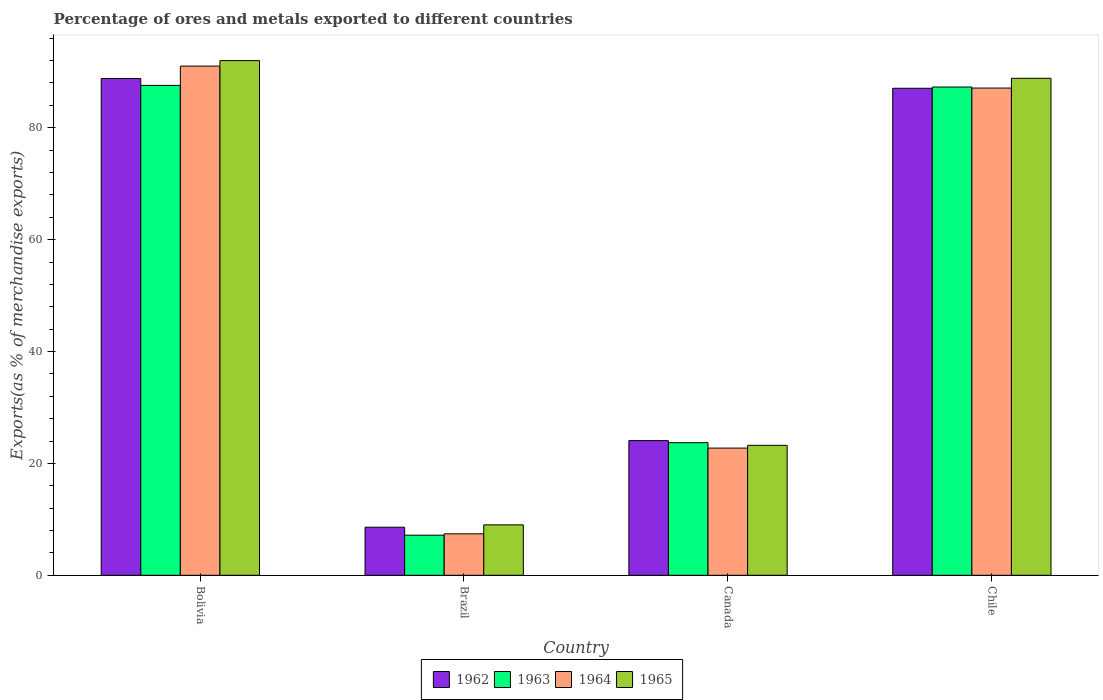How many bars are there on the 2nd tick from the left?
Your answer should be very brief. 4. What is the label of the 2nd group of bars from the left?
Provide a succinct answer. Brazil. What is the percentage of exports to different countries in 1962 in Brazil?
Your answer should be very brief. 8.59. Across all countries, what is the maximum percentage of exports to different countries in 1963?
Make the answer very short. 87.57. Across all countries, what is the minimum percentage of exports to different countries in 1965?
Make the answer very short. 9.01. In which country was the percentage of exports to different countries in 1963 maximum?
Your response must be concise. Bolivia. In which country was the percentage of exports to different countries in 1963 minimum?
Your answer should be very brief. Brazil. What is the total percentage of exports to different countries in 1965 in the graph?
Provide a short and direct response. 213.07. What is the difference between the percentage of exports to different countries in 1963 in Bolivia and that in Canada?
Your answer should be compact. 63.86. What is the difference between the percentage of exports to different countries in 1965 in Bolivia and the percentage of exports to different countries in 1964 in Chile?
Make the answer very short. 4.9. What is the average percentage of exports to different countries in 1963 per country?
Your response must be concise. 51.43. What is the difference between the percentage of exports to different countries of/in 1965 and percentage of exports to different countries of/in 1963 in Bolivia?
Provide a succinct answer. 4.43. What is the ratio of the percentage of exports to different countries in 1964 in Bolivia to that in Canada?
Give a very brief answer. 4. Is the difference between the percentage of exports to different countries in 1965 in Bolivia and Brazil greater than the difference between the percentage of exports to different countries in 1963 in Bolivia and Brazil?
Offer a very short reply. Yes. What is the difference between the highest and the second highest percentage of exports to different countries in 1965?
Offer a terse response. -3.16. What is the difference between the highest and the lowest percentage of exports to different countries in 1962?
Ensure brevity in your answer.  80.2. In how many countries, is the percentage of exports to different countries in 1963 greater than the average percentage of exports to different countries in 1963 taken over all countries?
Your answer should be very brief. 2. Is the sum of the percentage of exports to different countries in 1962 in Brazil and Canada greater than the maximum percentage of exports to different countries in 1963 across all countries?
Make the answer very short. No. Is it the case that in every country, the sum of the percentage of exports to different countries in 1965 and percentage of exports to different countries in 1964 is greater than the sum of percentage of exports to different countries in 1962 and percentage of exports to different countries in 1963?
Your answer should be compact. No. What does the 1st bar from the right in Brazil represents?
Make the answer very short. 1965. Are all the bars in the graph horizontal?
Make the answer very short. No. How many countries are there in the graph?
Make the answer very short. 4. Are the values on the major ticks of Y-axis written in scientific E-notation?
Your response must be concise. No. Does the graph contain any zero values?
Your answer should be compact. No. Where does the legend appear in the graph?
Your response must be concise. Bottom center. How many legend labels are there?
Offer a very short reply. 4. How are the legend labels stacked?
Your answer should be compact. Horizontal. What is the title of the graph?
Your answer should be very brief. Percentage of ores and metals exported to different countries. Does "1991" appear as one of the legend labels in the graph?
Offer a terse response. No. What is the label or title of the Y-axis?
Provide a short and direct response. Exports(as % of merchandise exports). What is the Exports(as % of merchandise exports) of 1962 in Bolivia?
Your answer should be very brief. 88.79. What is the Exports(as % of merchandise exports) in 1963 in Bolivia?
Give a very brief answer. 87.57. What is the Exports(as % of merchandise exports) of 1964 in Bolivia?
Give a very brief answer. 91.02. What is the Exports(as % of merchandise exports) in 1965 in Bolivia?
Make the answer very short. 92. What is the Exports(as % of merchandise exports) in 1962 in Brazil?
Offer a terse response. 8.59. What is the Exports(as % of merchandise exports) in 1963 in Brazil?
Provide a short and direct response. 7.17. What is the Exports(as % of merchandise exports) of 1964 in Brazil?
Offer a terse response. 7.41. What is the Exports(as % of merchandise exports) of 1965 in Brazil?
Offer a terse response. 9.01. What is the Exports(as % of merchandise exports) in 1962 in Canada?
Keep it short and to the point. 24.07. What is the Exports(as % of merchandise exports) in 1963 in Canada?
Your response must be concise. 23.71. What is the Exports(as % of merchandise exports) of 1964 in Canada?
Ensure brevity in your answer.  22.74. What is the Exports(as % of merchandise exports) in 1965 in Canada?
Your answer should be compact. 23.23. What is the Exports(as % of merchandise exports) in 1962 in Chile?
Keep it short and to the point. 87.06. What is the Exports(as % of merchandise exports) in 1963 in Chile?
Provide a succinct answer. 87.28. What is the Exports(as % of merchandise exports) of 1964 in Chile?
Offer a terse response. 87.1. What is the Exports(as % of merchandise exports) of 1965 in Chile?
Provide a succinct answer. 88.84. Across all countries, what is the maximum Exports(as % of merchandise exports) in 1962?
Keep it short and to the point. 88.79. Across all countries, what is the maximum Exports(as % of merchandise exports) in 1963?
Your answer should be compact. 87.57. Across all countries, what is the maximum Exports(as % of merchandise exports) of 1964?
Your answer should be very brief. 91.02. Across all countries, what is the maximum Exports(as % of merchandise exports) in 1965?
Offer a very short reply. 92. Across all countries, what is the minimum Exports(as % of merchandise exports) of 1962?
Make the answer very short. 8.59. Across all countries, what is the minimum Exports(as % of merchandise exports) in 1963?
Keep it short and to the point. 7.17. Across all countries, what is the minimum Exports(as % of merchandise exports) of 1964?
Provide a short and direct response. 7.41. Across all countries, what is the minimum Exports(as % of merchandise exports) in 1965?
Your response must be concise. 9.01. What is the total Exports(as % of merchandise exports) of 1962 in the graph?
Your answer should be compact. 208.51. What is the total Exports(as % of merchandise exports) of 1963 in the graph?
Ensure brevity in your answer.  205.73. What is the total Exports(as % of merchandise exports) in 1964 in the graph?
Your answer should be very brief. 208.26. What is the total Exports(as % of merchandise exports) of 1965 in the graph?
Keep it short and to the point. 213.07. What is the difference between the Exports(as % of merchandise exports) of 1962 in Bolivia and that in Brazil?
Ensure brevity in your answer.  80.2. What is the difference between the Exports(as % of merchandise exports) in 1963 in Bolivia and that in Brazil?
Your response must be concise. 80.4. What is the difference between the Exports(as % of merchandise exports) of 1964 in Bolivia and that in Brazil?
Your response must be concise. 83.61. What is the difference between the Exports(as % of merchandise exports) in 1965 in Bolivia and that in Brazil?
Your answer should be very brief. 82.99. What is the difference between the Exports(as % of merchandise exports) of 1962 in Bolivia and that in Canada?
Your response must be concise. 64.72. What is the difference between the Exports(as % of merchandise exports) of 1963 in Bolivia and that in Canada?
Offer a very short reply. 63.86. What is the difference between the Exports(as % of merchandise exports) in 1964 in Bolivia and that in Canada?
Provide a succinct answer. 68.28. What is the difference between the Exports(as % of merchandise exports) in 1965 in Bolivia and that in Canada?
Ensure brevity in your answer.  68.77. What is the difference between the Exports(as % of merchandise exports) of 1962 in Bolivia and that in Chile?
Provide a short and direct response. 1.74. What is the difference between the Exports(as % of merchandise exports) of 1963 in Bolivia and that in Chile?
Ensure brevity in your answer.  0.29. What is the difference between the Exports(as % of merchandise exports) in 1964 in Bolivia and that in Chile?
Keep it short and to the point. 3.92. What is the difference between the Exports(as % of merchandise exports) in 1965 in Bolivia and that in Chile?
Your answer should be very brief. 3.16. What is the difference between the Exports(as % of merchandise exports) in 1962 in Brazil and that in Canada?
Your answer should be compact. -15.48. What is the difference between the Exports(as % of merchandise exports) in 1963 in Brazil and that in Canada?
Your answer should be compact. -16.54. What is the difference between the Exports(as % of merchandise exports) of 1964 in Brazil and that in Canada?
Your answer should be compact. -15.33. What is the difference between the Exports(as % of merchandise exports) of 1965 in Brazil and that in Canada?
Offer a very short reply. -14.22. What is the difference between the Exports(as % of merchandise exports) of 1962 in Brazil and that in Chile?
Offer a terse response. -78.46. What is the difference between the Exports(as % of merchandise exports) in 1963 in Brazil and that in Chile?
Provide a short and direct response. -80.11. What is the difference between the Exports(as % of merchandise exports) of 1964 in Brazil and that in Chile?
Your answer should be compact. -79.69. What is the difference between the Exports(as % of merchandise exports) of 1965 in Brazil and that in Chile?
Keep it short and to the point. -79.83. What is the difference between the Exports(as % of merchandise exports) of 1962 in Canada and that in Chile?
Offer a terse response. -62.98. What is the difference between the Exports(as % of merchandise exports) of 1963 in Canada and that in Chile?
Your answer should be compact. -63.58. What is the difference between the Exports(as % of merchandise exports) of 1964 in Canada and that in Chile?
Offer a very short reply. -64.36. What is the difference between the Exports(as % of merchandise exports) of 1965 in Canada and that in Chile?
Ensure brevity in your answer.  -65.61. What is the difference between the Exports(as % of merchandise exports) of 1962 in Bolivia and the Exports(as % of merchandise exports) of 1963 in Brazil?
Offer a very short reply. 81.62. What is the difference between the Exports(as % of merchandise exports) of 1962 in Bolivia and the Exports(as % of merchandise exports) of 1964 in Brazil?
Give a very brief answer. 81.39. What is the difference between the Exports(as % of merchandise exports) of 1962 in Bolivia and the Exports(as % of merchandise exports) of 1965 in Brazil?
Offer a very short reply. 79.78. What is the difference between the Exports(as % of merchandise exports) of 1963 in Bolivia and the Exports(as % of merchandise exports) of 1964 in Brazil?
Offer a terse response. 80.16. What is the difference between the Exports(as % of merchandise exports) in 1963 in Bolivia and the Exports(as % of merchandise exports) in 1965 in Brazil?
Provide a short and direct response. 78.56. What is the difference between the Exports(as % of merchandise exports) of 1964 in Bolivia and the Exports(as % of merchandise exports) of 1965 in Brazil?
Give a very brief answer. 82.01. What is the difference between the Exports(as % of merchandise exports) of 1962 in Bolivia and the Exports(as % of merchandise exports) of 1963 in Canada?
Provide a short and direct response. 65.09. What is the difference between the Exports(as % of merchandise exports) in 1962 in Bolivia and the Exports(as % of merchandise exports) in 1964 in Canada?
Offer a very short reply. 66.06. What is the difference between the Exports(as % of merchandise exports) in 1962 in Bolivia and the Exports(as % of merchandise exports) in 1965 in Canada?
Provide a succinct answer. 65.57. What is the difference between the Exports(as % of merchandise exports) in 1963 in Bolivia and the Exports(as % of merchandise exports) in 1964 in Canada?
Your answer should be very brief. 64.83. What is the difference between the Exports(as % of merchandise exports) of 1963 in Bolivia and the Exports(as % of merchandise exports) of 1965 in Canada?
Your answer should be compact. 64.34. What is the difference between the Exports(as % of merchandise exports) in 1964 in Bolivia and the Exports(as % of merchandise exports) in 1965 in Canada?
Keep it short and to the point. 67.79. What is the difference between the Exports(as % of merchandise exports) in 1962 in Bolivia and the Exports(as % of merchandise exports) in 1963 in Chile?
Your answer should be very brief. 1.51. What is the difference between the Exports(as % of merchandise exports) of 1962 in Bolivia and the Exports(as % of merchandise exports) of 1964 in Chile?
Provide a succinct answer. 1.7. What is the difference between the Exports(as % of merchandise exports) of 1962 in Bolivia and the Exports(as % of merchandise exports) of 1965 in Chile?
Give a very brief answer. -0.04. What is the difference between the Exports(as % of merchandise exports) of 1963 in Bolivia and the Exports(as % of merchandise exports) of 1964 in Chile?
Your answer should be compact. 0.47. What is the difference between the Exports(as % of merchandise exports) in 1963 in Bolivia and the Exports(as % of merchandise exports) in 1965 in Chile?
Provide a short and direct response. -1.27. What is the difference between the Exports(as % of merchandise exports) of 1964 in Bolivia and the Exports(as % of merchandise exports) of 1965 in Chile?
Your answer should be very brief. 2.18. What is the difference between the Exports(as % of merchandise exports) of 1962 in Brazil and the Exports(as % of merchandise exports) of 1963 in Canada?
Give a very brief answer. -15.11. What is the difference between the Exports(as % of merchandise exports) of 1962 in Brazil and the Exports(as % of merchandise exports) of 1964 in Canada?
Ensure brevity in your answer.  -14.15. What is the difference between the Exports(as % of merchandise exports) of 1962 in Brazil and the Exports(as % of merchandise exports) of 1965 in Canada?
Ensure brevity in your answer.  -14.64. What is the difference between the Exports(as % of merchandise exports) in 1963 in Brazil and the Exports(as % of merchandise exports) in 1964 in Canada?
Provide a succinct answer. -15.57. What is the difference between the Exports(as % of merchandise exports) of 1963 in Brazil and the Exports(as % of merchandise exports) of 1965 in Canada?
Provide a succinct answer. -16.06. What is the difference between the Exports(as % of merchandise exports) in 1964 in Brazil and the Exports(as % of merchandise exports) in 1965 in Canada?
Your answer should be compact. -15.82. What is the difference between the Exports(as % of merchandise exports) of 1962 in Brazil and the Exports(as % of merchandise exports) of 1963 in Chile?
Your answer should be very brief. -78.69. What is the difference between the Exports(as % of merchandise exports) of 1962 in Brazil and the Exports(as % of merchandise exports) of 1964 in Chile?
Your answer should be very brief. -78.51. What is the difference between the Exports(as % of merchandise exports) in 1962 in Brazil and the Exports(as % of merchandise exports) in 1965 in Chile?
Your answer should be compact. -80.24. What is the difference between the Exports(as % of merchandise exports) of 1963 in Brazil and the Exports(as % of merchandise exports) of 1964 in Chile?
Offer a terse response. -79.93. What is the difference between the Exports(as % of merchandise exports) in 1963 in Brazil and the Exports(as % of merchandise exports) in 1965 in Chile?
Your response must be concise. -81.67. What is the difference between the Exports(as % of merchandise exports) in 1964 in Brazil and the Exports(as % of merchandise exports) in 1965 in Chile?
Provide a succinct answer. -81.43. What is the difference between the Exports(as % of merchandise exports) in 1962 in Canada and the Exports(as % of merchandise exports) in 1963 in Chile?
Your response must be concise. -63.21. What is the difference between the Exports(as % of merchandise exports) of 1962 in Canada and the Exports(as % of merchandise exports) of 1964 in Chile?
Your response must be concise. -63.03. What is the difference between the Exports(as % of merchandise exports) in 1962 in Canada and the Exports(as % of merchandise exports) in 1965 in Chile?
Your answer should be very brief. -64.76. What is the difference between the Exports(as % of merchandise exports) in 1963 in Canada and the Exports(as % of merchandise exports) in 1964 in Chile?
Offer a very short reply. -63.39. What is the difference between the Exports(as % of merchandise exports) of 1963 in Canada and the Exports(as % of merchandise exports) of 1965 in Chile?
Provide a succinct answer. -65.13. What is the difference between the Exports(as % of merchandise exports) of 1964 in Canada and the Exports(as % of merchandise exports) of 1965 in Chile?
Provide a succinct answer. -66.1. What is the average Exports(as % of merchandise exports) in 1962 per country?
Keep it short and to the point. 52.13. What is the average Exports(as % of merchandise exports) in 1963 per country?
Your answer should be compact. 51.43. What is the average Exports(as % of merchandise exports) in 1964 per country?
Provide a short and direct response. 52.07. What is the average Exports(as % of merchandise exports) of 1965 per country?
Provide a short and direct response. 53.27. What is the difference between the Exports(as % of merchandise exports) of 1962 and Exports(as % of merchandise exports) of 1963 in Bolivia?
Make the answer very short. 1.22. What is the difference between the Exports(as % of merchandise exports) of 1962 and Exports(as % of merchandise exports) of 1964 in Bolivia?
Your answer should be compact. -2.22. What is the difference between the Exports(as % of merchandise exports) of 1962 and Exports(as % of merchandise exports) of 1965 in Bolivia?
Give a very brief answer. -3.21. What is the difference between the Exports(as % of merchandise exports) in 1963 and Exports(as % of merchandise exports) in 1964 in Bolivia?
Make the answer very short. -3.45. What is the difference between the Exports(as % of merchandise exports) of 1963 and Exports(as % of merchandise exports) of 1965 in Bolivia?
Ensure brevity in your answer.  -4.43. What is the difference between the Exports(as % of merchandise exports) in 1964 and Exports(as % of merchandise exports) in 1965 in Bolivia?
Ensure brevity in your answer.  -0.98. What is the difference between the Exports(as % of merchandise exports) in 1962 and Exports(as % of merchandise exports) in 1963 in Brazil?
Make the answer very short. 1.42. What is the difference between the Exports(as % of merchandise exports) of 1962 and Exports(as % of merchandise exports) of 1964 in Brazil?
Provide a succinct answer. 1.18. What is the difference between the Exports(as % of merchandise exports) in 1962 and Exports(as % of merchandise exports) in 1965 in Brazil?
Your answer should be very brief. -0.42. What is the difference between the Exports(as % of merchandise exports) of 1963 and Exports(as % of merchandise exports) of 1964 in Brazil?
Keep it short and to the point. -0.24. What is the difference between the Exports(as % of merchandise exports) in 1963 and Exports(as % of merchandise exports) in 1965 in Brazil?
Your answer should be compact. -1.84. What is the difference between the Exports(as % of merchandise exports) in 1964 and Exports(as % of merchandise exports) in 1965 in Brazil?
Your answer should be compact. -1.6. What is the difference between the Exports(as % of merchandise exports) in 1962 and Exports(as % of merchandise exports) in 1963 in Canada?
Make the answer very short. 0.37. What is the difference between the Exports(as % of merchandise exports) in 1962 and Exports(as % of merchandise exports) in 1964 in Canada?
Make the answer very short. 1.33. What is the difference between the Exports(as % of merchandise exports) in 1962 and Exports(as % of merchandise exports) in 1965 in Canada?
Keep it short and to the point. 0.84. What is the difference between the Exports(as % of merchandise exports) in 1963 and Exports(as % of merchandise exports) in 1964 in Canada?
Provide a short and direct response. 0.97. What is the difference between the Exports(as % of merchandise exports) in 1963 and Exports(as % of merchandise exports) in 1965 in Canada?
Offer a very short reply. 0.48. What is the difference between the Exports(as % of merchandise exports) in 1964 and Exports(as % of merchandise exports) in 1965 in Canada?
Your answer should be very brief. -0.49. What is the difference between the Exports(as % of merchandise exports) in 1962 and Exports(as % of merchandise exports) in 1963 in Chile?
Provide a succinct answer. -0.23. What is the difference between the Exports(as % of merchandise exports) in 1962 and Exports(as % of merchandise exports) in 1964 in Chile?
Keep it short and to the point. -0.04. What is the difference between the Exports(as % of merchandise exports) of 1962 and Exports(as % of merchandise exports) of 1965 in Chile?
Ensure brevity in your answer.  -1.78. What is the difference between the Exports(as % of merchandise exports) in 1963 and Exports(as % of merchandise exports) in 1964 in Chile?
Offer a very short reply. 0.18. What is the difference between the Exports(as % of merchandise exports) in 1963 and Exports(as % of merchandise exports) in 1965 in Chile?
Your answer should be very brief. -1.55. What is the difference between the Exports(as % of merchandise exports) in 1964 and Exports(as % of merchandise exports) in 1965 in Chile?
Make the answer very short. -1.74. What is the ratio of the Exports(as % of merchandise exports) in 1962 in Bolivia to that in Brazil?
Ensure brevity in your answer.  10.33. What is the ratio of the Exports(as % of merchandise exports) of 1963 in Bolivia to that in Brazil?
Your answer should be compact. 12.21. What is the ratio of the Exports(as % of merchandise exports) of 1964 in Bolivia to that in Brazil?
Keep it short and to the point. 12.29. What is the ratio of the Exports(as % of merchandise exports) of 1965 in Bolivia to that in Brazil?
Keep it short and to the point. 10.21. What is the ratio of the Exports(as % of merchandise exports) of 1962 in Bolivia to that in Canada?
Make the answer very short. 3.69. What is the ratio of the Exports(as % of merchandise exports) of 1963 in Bolivia to that in Canada?
Offer a terse response. 3.69. What is the ratio of the Exports(as % of merchandise exports) of 1964 in Bolivia to that in Canada?
Provide a short and direct response. 4. What is the ratio of the Exports(as % of merchandise exports) in 1965 in Bolivia to that in Canada?
Make the answer very short. 3.96. What is the ratio of the Exports(as % of merchandise exports) in 1964 in Bolivia to that in Chile?
Offer a very short reply. 1.04. What is the ratio of the Exports(as % of merchandise exports) in 1965 in Bolivia to that in Chile?
Give a very brief answer. 1.04. What is the ratio of the Exports(as % of merchandise exports) in 1962 in Brazil to that in Canada?
Keep it short and to the point. 0.36. What is the ratio of the Exports(as % of merchandise exports) in 1963 in Brazil to that in Canada?
Keep it short and to the point. 0.3. What is the ratio of the Exports(as % of merchandise exports) in 1964 in Brazil to that in Canada?
Your answer should be compact. 0.33. What is the ratio of the Exports(as % of merchandise exports) of 1965 in Brazil to that in Canada?
Offer a very short reply. 0.39. What is the ratio of the Exports(as % of merchandise exports) of 1962 in Brazil to that in Chile?
Provide a short and direct response. 0.1. What is the ratio of the Exports(as % of merchandise exports) in 1963 in Brazil to that in Chile?
Offer a terse response. 0.08. What is the ratio of the Exports(as % of merchandise exports) in 1964 in Brazil to that in Chile?
Your answer should be very brief. 0.09. What is the ratio of the Exports(as % of merchandise exports) in 1965 in Brazil to that in Chile?
Make the answer very short. 0.1. What is the ratio of the Exports(as % of merchandise exports) in 1962 in Canada to that in Chile?
Offer a very short reply. 0.28. What is the ratio of the Exports(as % of merchandise exports) of 1963 in Canada to that in Chile?
Your response must be concise. 0.27. What is the ratio of the Exports(as % of merchandise exports) in 1964 in Canada to that in Chile?
Offer a very short reply. 0.26. What is the ratio of the Exports(as % of merchandise exports) of 1965 in Canada to that in Chile?
Your answer should be compact. 0.26. What is the difference between the highest and the second highest Exports(as % of merchandise exports) in 1962?
Offer a very short reply. 1.74. What is the difference between the highest and the second highest Exports(as % of merchandise exports) of 1963?
Offer a terse response. 0.29. What is the difference between the highest and the second highest Exports(as % of merchandise exports) of 1964?
Make the answer very short. 3.92. What is the difference between the highest and the second highest Exports(as % of merchandise exports) of 1965?
Ensure brevity in your answer.  3.16. What is the difference between the highest and the lowest Exports(as % of merchandise exports) of 1962?
Give a very brief answer. 80.2. What is the difference between the highest and the lowest Exports(as % of merchandise exports) of 1963?
Your answer should be compact. 80.4. What is the difference between the highest and the lowest Exports(as % of merchandise exports) in 1964?
Provide a succinct answer. 83.61. What is the difference between the highest and the lowest Exports(as % of merchandise exports) of 1965?
Your answer should be compact. 82.99. 